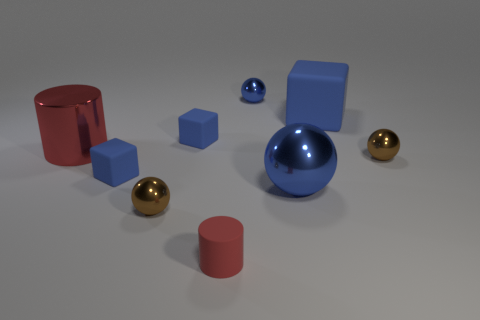Which objects in the image seem to have a metallic texture? The three spherical objects exhibit a metallic texture. Two are gold and one is silver in color, reflecting light and showing off a shiny finish that is characteristic of metal. 